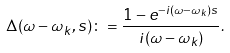<formula> <loc_0><loc_0><loc_500><loc_500>\Delta ( \omega - \omega _ { k } , s ) \colon = \frac { 1 - e ^ { - i ( \omega - \omega _ { k } ) s } } { i ( \omega - \omega _ { k } ) } .</formula> 